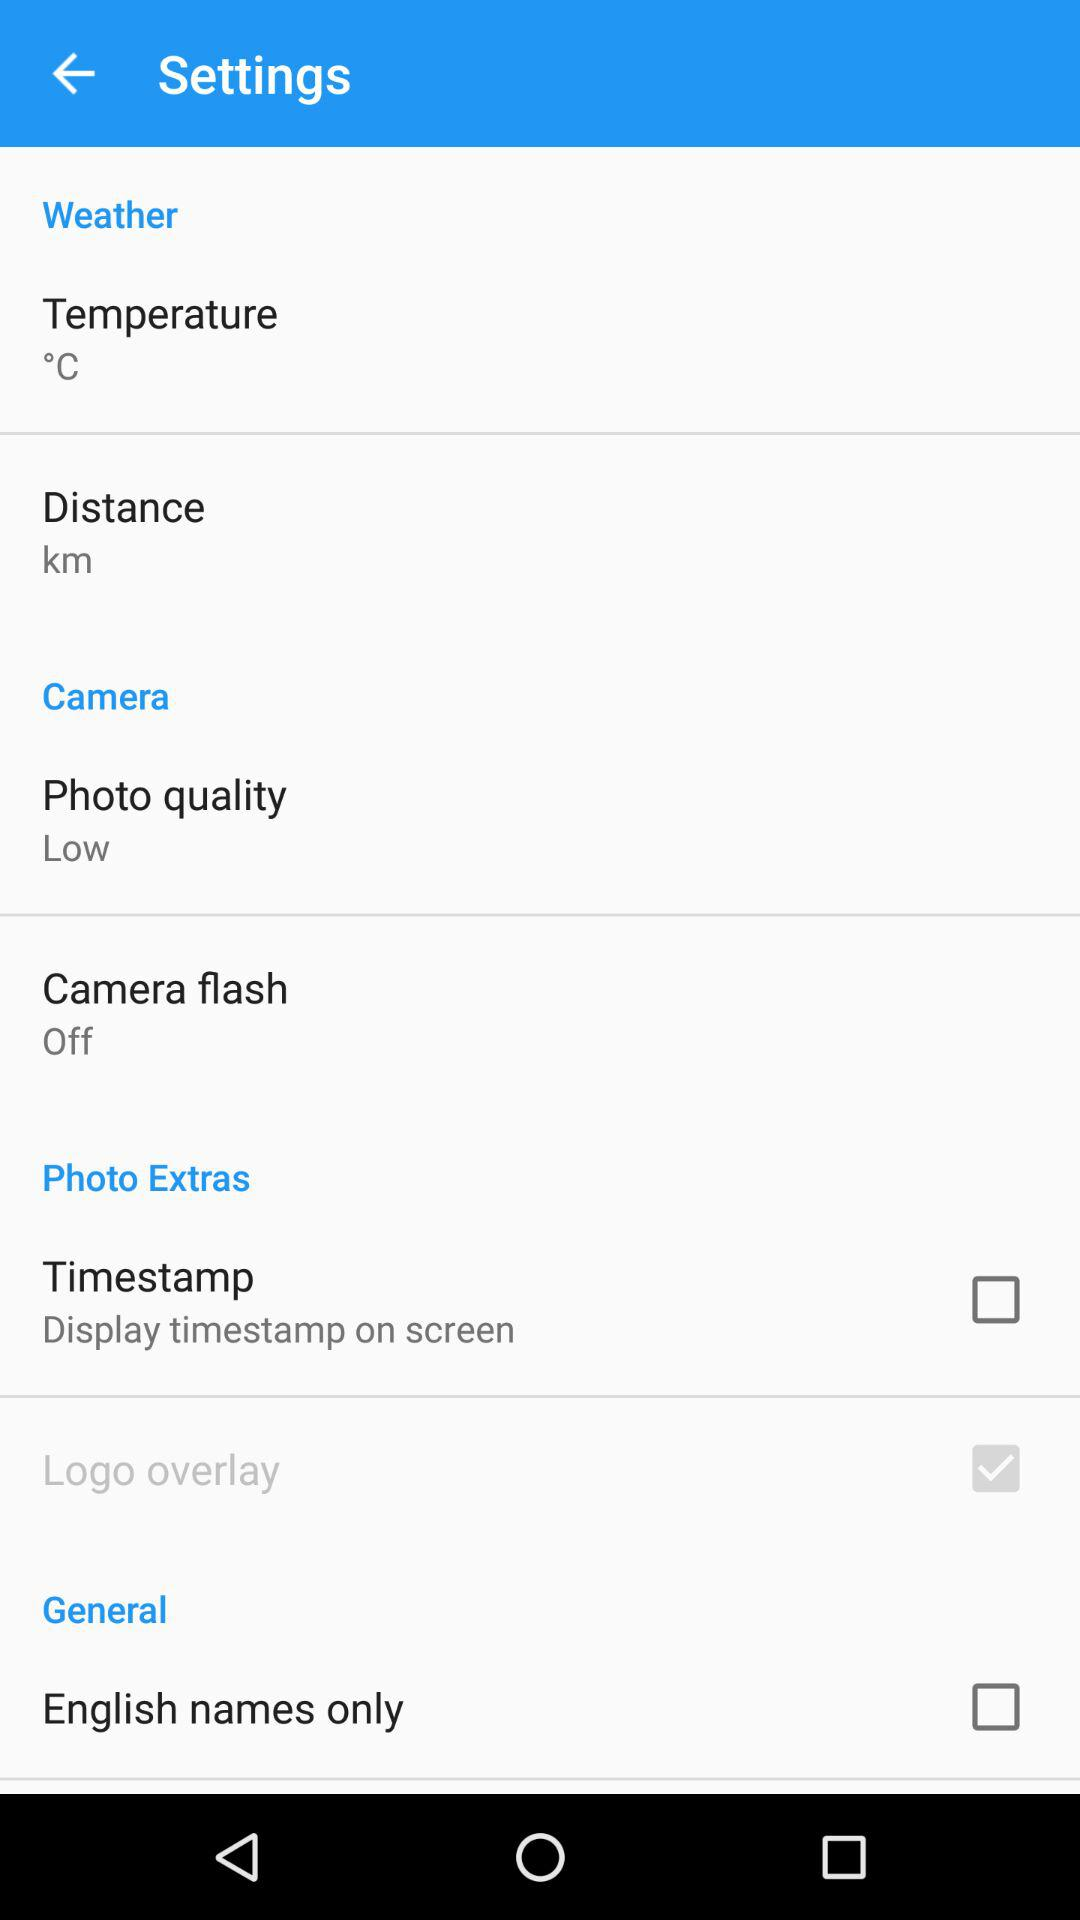What is the temperature unit? The temperature unit is °C. 